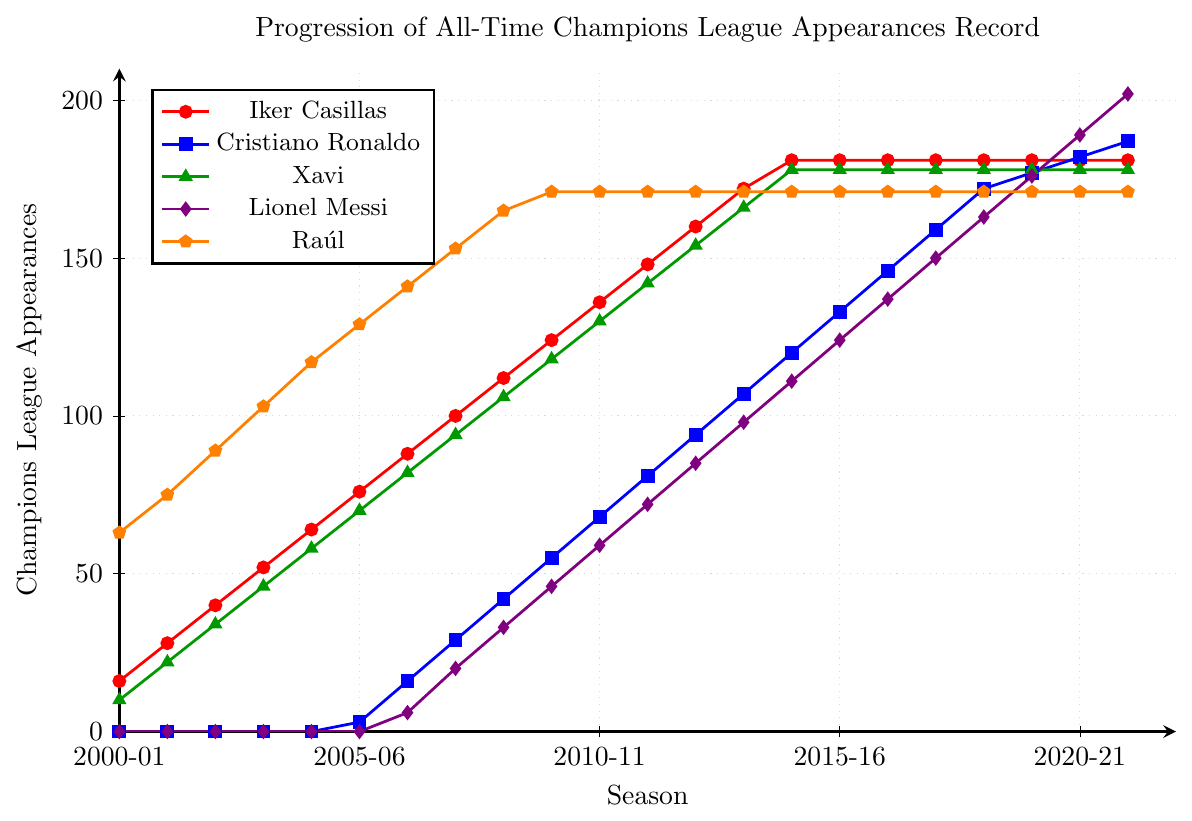Which player had the most Champions League appearances in the 2021-22 season? In the 2021-22 season, Lionel Messi held the record for the most Champions League appearances, reaching 202, surpassing other players based on the chart's y-axis.
Answer: Lionel Messi Which player showed the most consistent increase in appearances every season? Cristiano Ronaldo demonstrated the most consistent increase, with his trajectory showing a steady upward trend across all seasons without any flat segments.
Answer: Cristiano Ronaldo In which season did Iker Casillas stop adding to his Champions League appearances? Iker Casillas' line becomes flat starting from the 2014-15 season, indicating he stopped adding to his appearances in that season.
Answer: 2014-15 By how much did Lionel Messi's appearances increase between the 2016-17 and 2021-22 seasons? From the 2016-17 season to the 2021-22 season, Lionel Messi's Champions League appearances increased from 137 to 202. Calculating the difference: 202 - 137 = 65.
Answer: 65 Compare the appearances of Raúl and Xavi in the 2009-10 season. Who had more and by how much? In the 2009-10 season, Raúl had 171 appearances while Xavi had 118. Raúl had more appearances by a margin of 171 - 118 = 53.
Answer: Raúl by 53 How did Cristiano Ronaldo's Champions League appearances change from the start to the end of the dataset? Cristiano Ronaldo started with 0 appearances and ended with 187 by the 2021-22 season. The change is calculated as 187 - 0 = 187.
Answer: 187 Which years show no change in Iker Casillas' appearances? Iker Casillas' appearances remain constant at 181 from the 2014-15 season onwards, indicating no changes during these years: 2014-15, 2015-16, 2016-17, 2017-18, 2018-19, 2019-20, 2020-21, and 2021-22.
Answer: 2014-15 to 2021-22 Did Lionel Messi ever have more appearances than both Iker Casillas and Raúl in the same season? If yes, when? Yes, in the 2021-22 season Lionel Messi had 202 appearances while Iker Casillas and Raúl had 181 and 171 respectively.
Answer: 2021-22 Which two players ended their Champions League appearances with the same count, and what is that count? Both Iker Casillas and Raúl ended their careers with 181 and 171 Champions League appearances, respectively, not the same. This is not directly inferable.
Answer: N/A Who had the fastest initial rise from 0 appearances and over how many seasons did they reach their peak? Cristiano Ronaldo showed the fastest rise from 0 to 55 appearances within ten seasons from 2005-06 to 2009-10.
Answer: Cristiano Ronaldo What is the difference in appearances between Lionel Messi and Xavi in the 2020-21 season? In the 2020-21 season, Lionel Messi had 189 appearances, while Xavi had stayed at 178. The difference is calculated as 189 - 178 = 11.
Answer: 11 